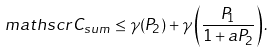Convert formula to latex. <formula><loc_0><loc_0><loc_500><loc_500>\ m a t h s c r { C } _ { s u m } \leq \gamma ( P _ { 2 } ) + \gamma \left ( \frac { P _ { 1 } } { 1 + a P _ { 2 } } \right ) .</formula> 